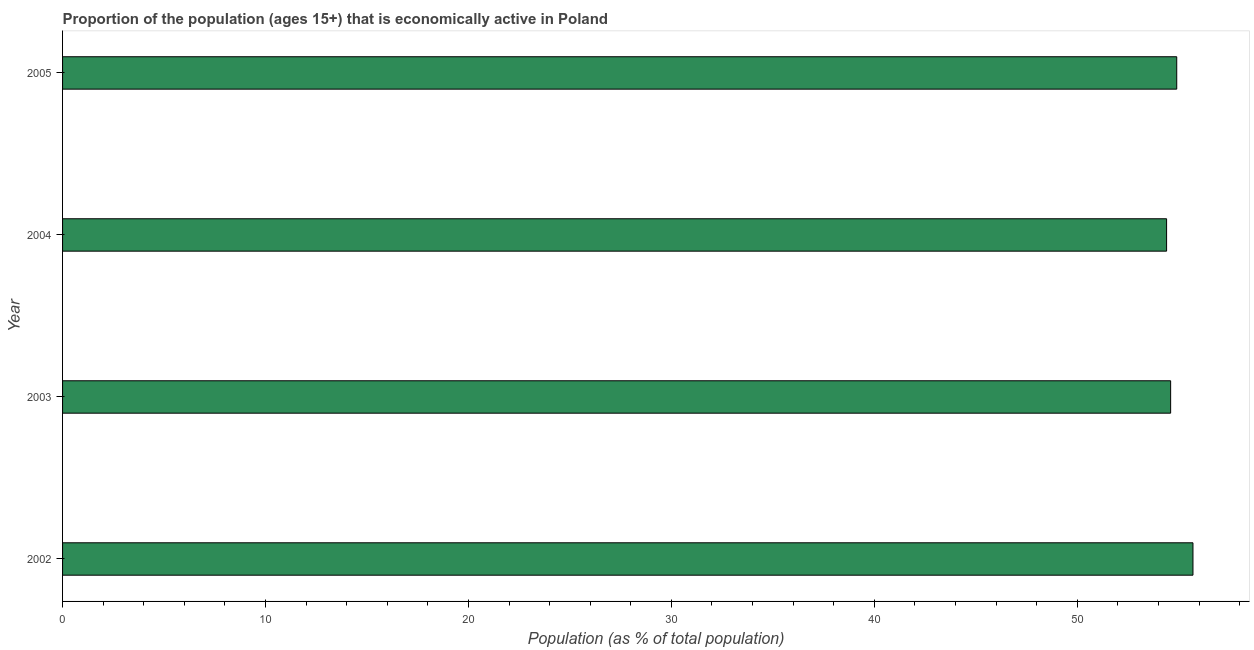Does the graph contain any zero values?
Provide a short and direct response. No. Does the graph contain grids?
Provide a succinct answer. No. What is the title of the graph?
Offer a very short reply. Proportion of the population (ages 15+) that is economically active in Poland. What is the label or title of the X-axis?
Offer a terse response. Population (as % of total population). What is the label or title of the Y-axis?
Your answer should be compact. Year. What is the percentage of economically active population in 2005?
Provide a succinct answer. 54.9. Across all years, what is the maximum percentage of economically active population?
Your answer should be very brief. 55.7. Across all years, what is the minimum percentage of economically active population?
Provide a short and direct response. 54.4. In which year was the percentage of economically active population maximum?
Your answer should be very brief. 2002. What is the sum of the percentage of economically active population?
Keep it short and to the point. 219.6. What is the average percentage of economically active population per year?
Give a very brief answer. 54.9. What is the median percentage of economically active population?
Your answer should be compact. 54.75. What is the ratio of the percentage of economically active population in 2003 to that in 2004?
Offer a terse response. 1. Is the difference between the percentage of economically active population in 2002 and 2005 greater than the difference between any two years?
Offer a terse response. No. What is the difference between the highest and the lowest percentage of economically active population?
Offer a terse response. 1.3. In how many years, is the percentage of economically active population greater than the average percentage of economically active population taken over all years?
Offer a very short reply. 2. How many years are there in the graph?
Your answer should be very brief. 4. What is the Population (as % of total population) of 2002?
Keep it short and to the point. 55.7. What is the Population (as % of total population) in 2003?
Your answer should be compact. 54.6. What is the Population (as % of total population) in 2004?
Keep it short and to the point. 54.4. What is the Population (as % of total population) in 2005?
Provide a succinct answer. 54.9. What is the difference between the Population (as % of total population) in 2002 and 2003?
Ensure brevity in your answer.  1.1. What is the difference between the Population (as % of total population) in 2002 and 2004?
Keep it short and to the point. 1.3. What is the difference between the Population (as % of total population) in 2003 and 2004?
Offer a terse response. 0.2. What is the difference between the Population (as % of total population) in 2003 and 2005?
Give a very brief answer. -0.3. What is the ratio of the Population (as % of total population) in 2002 to that in 2004?
Provide a short and direct response. 1.02. What is the ratio of the Population (as % of total population) in 2003 to that in 2004?
Offer a very short reply. 1. 